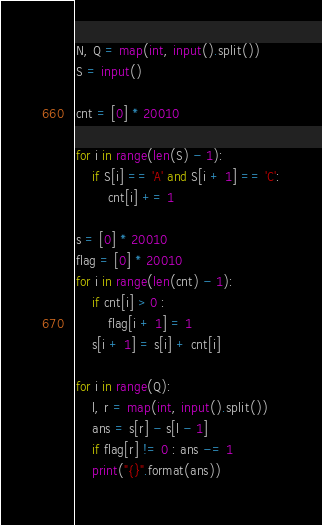<code> <loc_0><loc_0><loc_500><loc_500><_Python_>N, Q = map(int, input().split())
S = input()

cnt = [0] * 20010

for i in range(len(S) - 1):
    if S[i] == 'A' and S[i + 1] == 'C':
        cnt[i] += 1

s = [0] * 20010
flag = [0] * 20010
for i in range(len(cnt) - 1):
    if cnt[i] > 0 :
        flag[i + 1] = 1
    s[i + 1] = s[i] + cnt[i]

for i in range(Q):
    l, r = map(int, input().split())
    ans = s[r] - s[l - 1]
    if flag[r] != 0 : ans -= 1
    print("{}".format(ans))</code> 